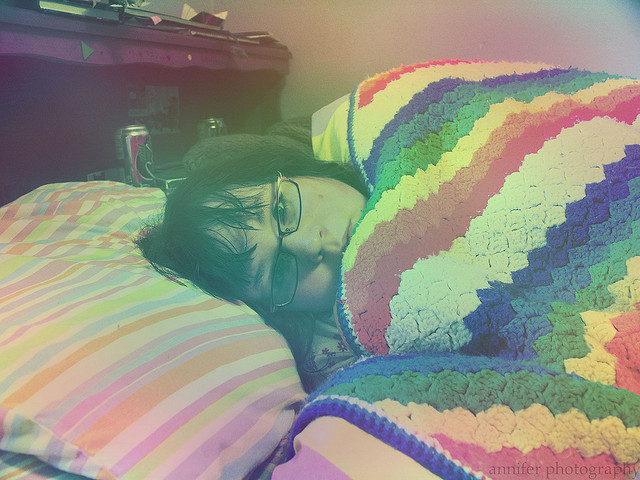Identify and read out the text in this image. photography 